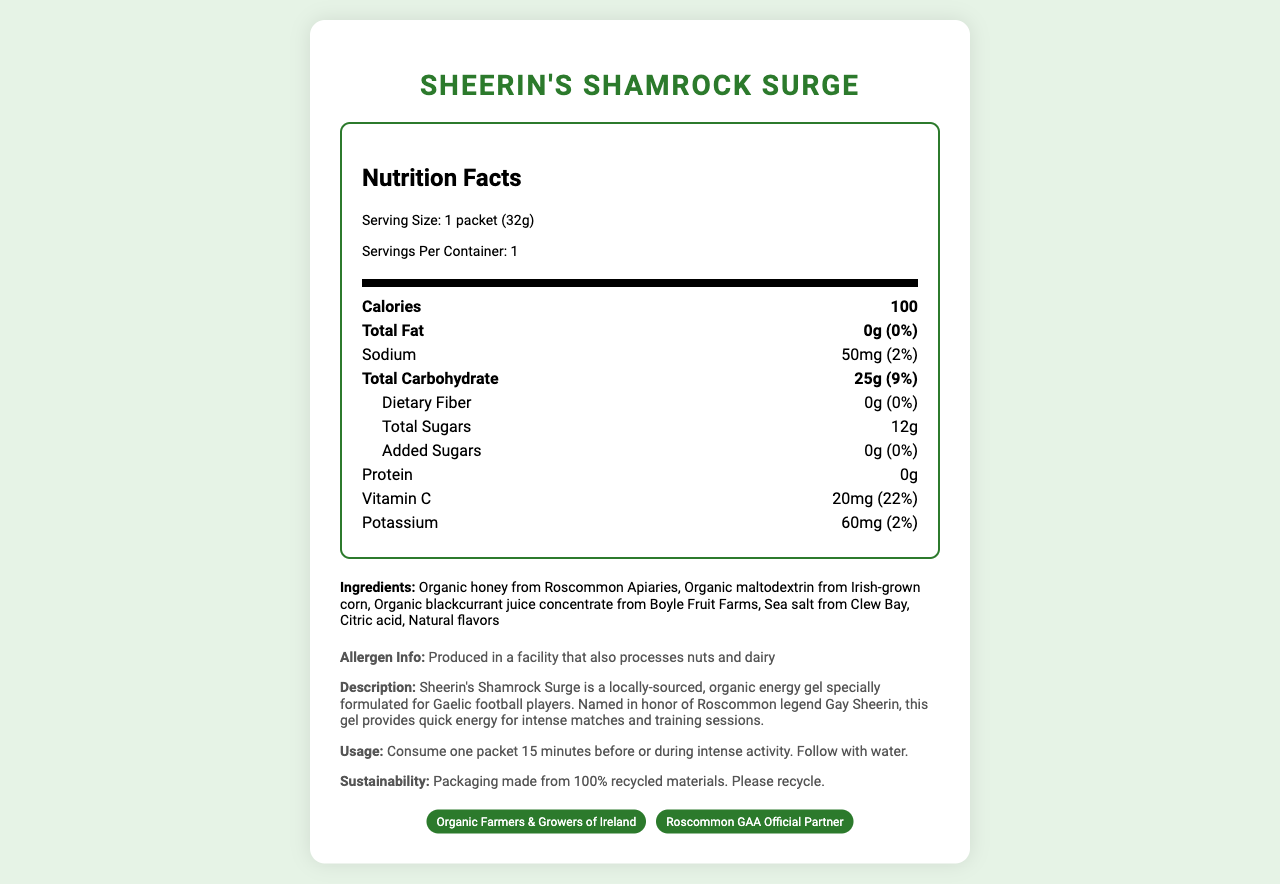what is the serving size of Sheerin's Shamrock Surge? The serving size is listed as "1 packet (32g)" within the nutrition section of the document.
Answer: 1 packet (32g) how many calories are in one serving? The number of calories per serving is listed as "100" in the nutrition facts.
Answer: 100 what amount of sodium does one packet contain? The sodium content per packet is listed as "50mg" in the nutrition facts.
Answer: 50mg what are the primary ingredients in Sheerin's Shamrock Surge? The primary ingredients are listed in the ingredients section.
Answer: Organic honey from Roscommon Apiaries, Organic maltodextrin from Irish-grown corn, Organic blackcurrant juice concentrate from Boyle Fruit Farms, Sea salt from Clew Bay, Citric acid, Natural flavors who is Sheerin's Shamrock Surge named after? It is mentioned in the description that the product is named in honor of Roscommon legend Gay Sheerin.
Answer: Gay Sheerin what percentage of daily value for Vitamin C does Sheerin's Shamrock Surge provide? The document states that the Vitamin C content is 20mg, which is 22% of the daily value.
Answer: 22% does Sheerin's Shamrock Surge contain any added sugars? The total added sugars are listed as "0g" in the nutrition facts.
Answer: No what is the sustainability note mentioned in the document? The sustainability note indicates that the packaging is made from 100% recycled materials and encourages recycling.
Answer: Packaging made from 100% recycled materials. Please recycle. which certification does NOT belong to Sheerin's Shamrock Surge? A. Organic Farmers & Growers of Ireland B. European Organic Certification C. Roscommon GAA Official Partner The listed certifications are "Organic Farmers & Growers of Ireland" and "Roscommon GAA Official Partner," but not "European Organic Certification."
Answer: B how much total carbohydrate is in one packet? A. 15g B. 20g C. 25g D. 30g The total carbohydrate content in one packet is listed as "25g" in the nutrition facts.
Answer: C does the product contain any protein? The protein content is listed as "0g" in the nutrition facts.
Answer: No is Sheerin's Shamrock Surge suitable for people with nut allergies? The allergen info section mentions that the product is produced in a facility that also processes nuts, so it may not be suitable for those with nut allergies.
Answer: No summarize the nutrition and ingredient information of Sheerin's Shamrock Surge. The summary covers key nutritional information, ingredients, and allergen details.
Answer: Sheerin's Shamrock Surge is an organic energy gel with 100 calories per serving (one packet, 32g), containing 0g total fat, 50mg sodium, 25g total carbohydrate with 12g total sugars (0g added sugars), 0g protein, 20mg Vitamin C (22% DV), and 60mg potassium (2% DV). The primary ingredients include organic honey, maltodextrin, blackcurrant juice concentrate, sea salt, citric acid, and natural flavors. It is produced in a facility that processes nuts and dairy. what is the company's mission statement? The document does not provide information about the company's mission statement, so the exact mission cannot be determined.
Answer: Not enough information 